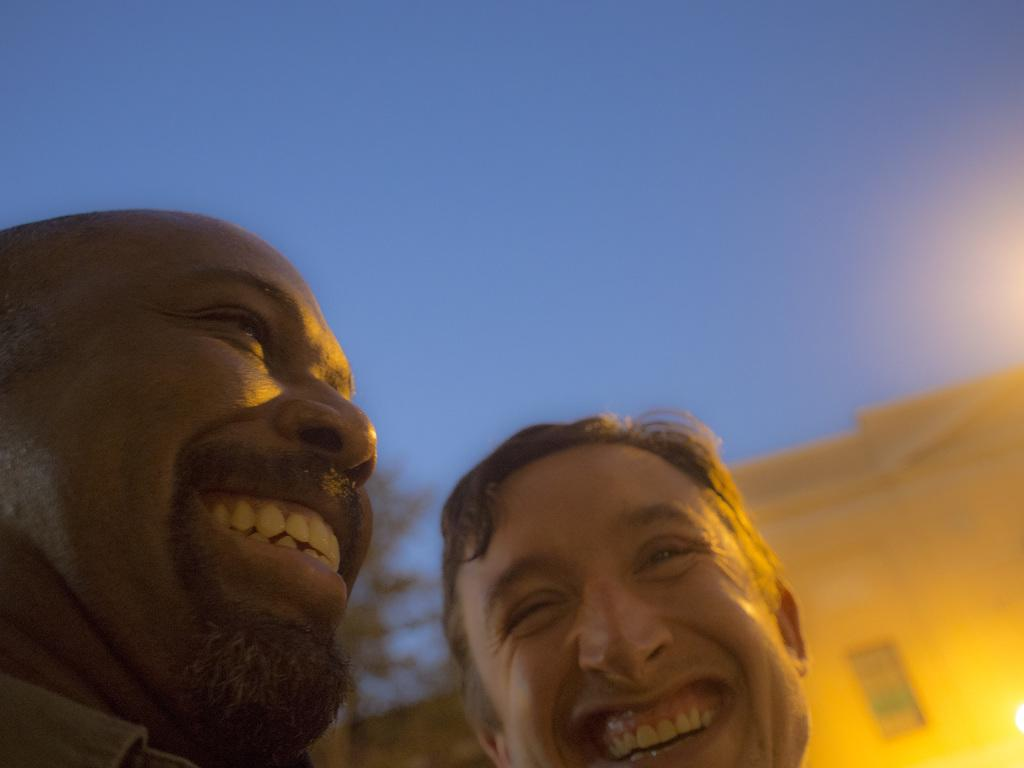How many people are present in the image? There are two persons in the image. What can be seen in the background of the image? There is a building and a tree in the background of the image. What is visible at the top of the image? The sky is visible at the top of the image. What type of curtain can be seen hanging from the tree in the image? There is no curtain present in the image, and the tree does not have any hanging from it. 